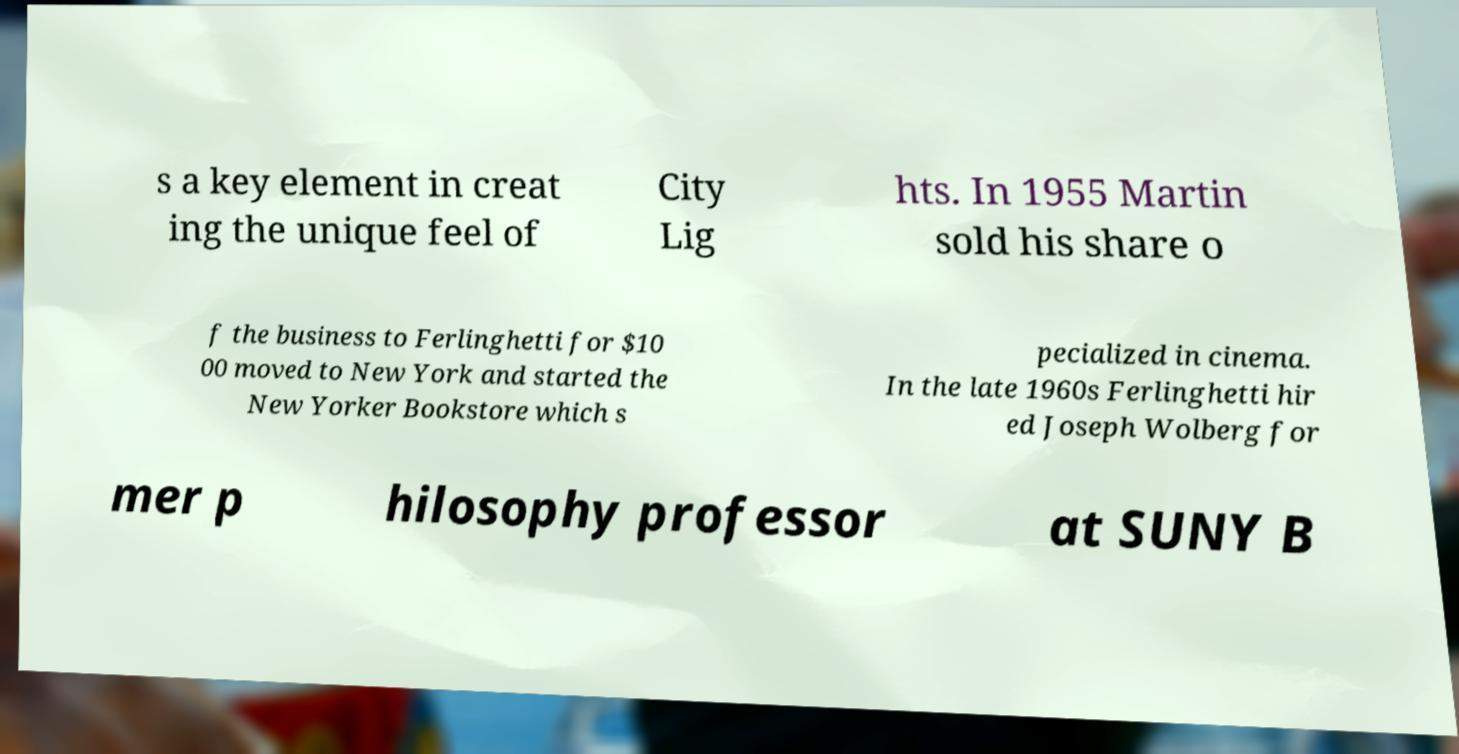Can you accurately transcribe the text from the provided image for me? s a key element in creat ing the unique feel of City Lig hts. In 1955 Martin sold his share o f the business to Ferlinghetti for $10 00 moved to New York and started the New Yorker Bookstore which s pecialized in cinema. In the late 1960s Ferlinghetti hir ed Joseph Wolberg for mer p hilosophy professor at SUNY B 